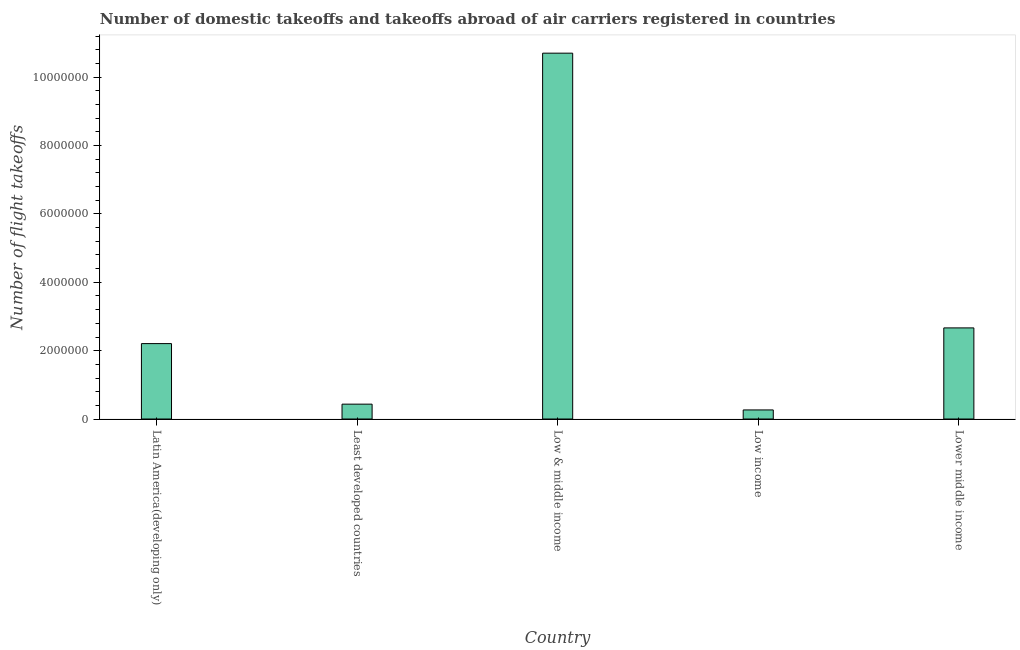Does the graph contain grids?
Your answer should be very brief. No. What is the title of the graph?
Offer a terse response. Number of domestic takeoffs and takeoffs abroad of air carriers registered in countries. What is the label or title of the X-axis?
Provide a short and direct response. Country. What is the label or title of the Y-axis?
Offer a terse response. Number of flight takeoffs. What is the number of flight takeoffs in Low & middle income?
Your answer should be very brief. 1.07e+07. Across all countries, what is the maximum number of flight takeoffs?
Your answer should be very brief. 1.07e+07. Across all countries, what is the minimum number of flight takeoffs?
Your answer should be compact. 2.66e+05. In which country was the number of flight takeoffs maximum?
Give a very brief answer. Low & middle income. In which country was the number of flight takeoffs minimum?
Offer a very short reply. Low income. What is the sum of the number of flight takeoffs?
Your response must be concise. 1.63e+07. What is the difference between the number of flight takeoffs in Latin America(developing only) and Low & middle income?
Offer a very short reply. -8.50e+06. What is the average number of flight takeoffs per country?
Make the answer very short. 3.26e+06. What is the median number of flight takeoffs?
Provide a succinct answer. 2.21e+06. What is the ratio of the number of flight takeoffs in Least developed countries to that in Low income?
Keep it short and to the point. 1.64. Is the number of flight takeoffs in Latin America(developing only) less than that in Low & middle income?
Offer a terse response. Yes. Is the difference between the number of flight takeoffs in Low & middle income and Low income greater than the difference between any two countries?
Offer a terse response. Yes. What is the difference between the highest and the second highest number of flight takeoffs?
Your answer should be very brief. 8.04e+06. Is the sum of the number of flight takeoffs in Latin America(developing only) and Lower middle income greater than the maximum number of flight takeoffs across all countries?
Your response must be concise. No. What is the difference between the highest and the lowest number of flight takeoffs?
Ensure brevity in your answer.  1.04e+07. Are all the bars in the graph horizontal?
Provide a short and direct response. No. What is the Number of flight takeoffs of Latin America(developing only)?
Your response must be concise. 2.21e+06. What is the Number of flight takeoffs of Least developed countries?
Your answer should be compact. 4.35e+05. What is the Number of flight takeoffs of Low & middle income?
Give a very brief answer. 1.07e+07. What is the Number of flight takeoffs in Low income?
Ensure brevity in your answer.  2.66e+05. What is the Number of flight takeoffs in Lower middle income?
Make the answer very short. 2.67e+06. What is the difference between the Number of flight takeoffs in Latin America(developing only) and Least developed countries?
Offer a terse response. 1.77e+06. What is the difference between the Number of flight takeoffs in Latin America(developing only) and Low & middle income?
Offer a terse response. -8.50e+06. What is the difference between the Number of flight takeoffs in Latin America(developing only) and Low income?
Provide a succinct answer. 1.94e+06. What is the difference between the Number of flight takeoffs in Latin America(developing only) and Lower middle income?
Your answer should be very brief. -4.59e+05. What is the difference between the Number of flight takeoffs in Least developed countries and Low & middle income?
Your answer should be very brief. -1.03e+07. What is the difference between the Number of flight takeoffs in Least developed countries and Low income?
Make the answer very short. 1.69e+05. What is the difference between the Number of flight takeoffs in Least developed countries and Lower middle income?
Offer a very short reply. -2.23e+06. What is the difference between the Number of flight takeoffs in Low & middle income and Low income?
Make the answer very short. 1.04e+07. What is the difference between the Number of flight takeoffs in Low & middle income and Lower middle income?
Provide a succinct answer. 8.04e+06. What is the difference between the Number of flight takeoffs in Low income and Lower middle income?
Ensure brevity in your answer.  -2.40e+06. What is the ratio of the Number of flight takeoffs in Latin America(developing only) to that in Least developed countries?
Give a very brief answer. 5.07. What is the ratio of the Number of flight takeoffs in Latin America(developing only) to that in Low & middle income?
Make the answer very short. 0.21. What is the ratio of the Number of flight takeoffs in Latin America(developing only) to that in Lower middle income?
Your answer should be compact. 0.83. What is the ratio of the Number of flight takeoffs in Least developed countries to that in Low & middle income?
Keep it short and to the point. 0.04. What is the ratio of the Number of flight takeoffs in Least developed countries to that in Low income?
Your response must be concise. 1.64. What is the ratio of the Number of flight takeoffs in Least developed countries to that in Lower middle income?
Your answer should be compact. 0.16. What is the ratio of the Number of flight takeoffs in Low & middle income to that in Low income?
Provide a succinct answer. 40.26. What is the ratio of the Number of flight takeoffs in Low & middle income to that in Lower middle income?
Offer a terse response. 4.01. 